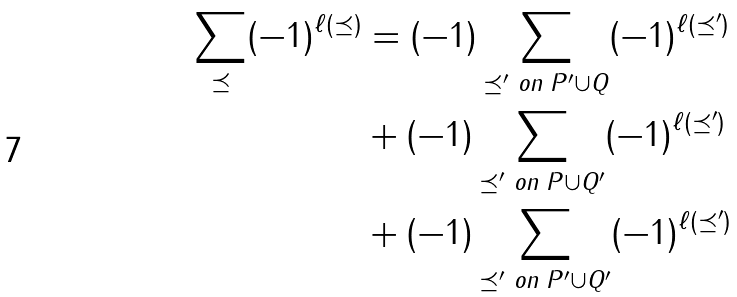Convert formula to latex. <formula><loc_0><loc_0><loc_500><loc_500>\sum _ { \preceq } ( - 1 ) ^ { \ell ( \preceq ) } & = ( - 1 ) \sum _ { \preceq ^ { \prime } \text { on } P ^ { \prime } \cup Q } ( - 1 ) ^ { \ell ( \preceq ^ { \prime } ) } \\ & + ( - 1 ) \sum _ { \preceq ^ { \prime } \text { on } P \cup Q ^ { \prime } } ( - 1 ) ^ { \ell ( \preceq ^ { \prime } ) } \\ & + ( - 1 ) \sum _ { \preceq ^ { \prime } \text { on } P ^ { \prime } \cup Q ^ { \prime } } ( - 1 ) ^ { \ell ( \preceq ^ { \prime } ) }</formula> 